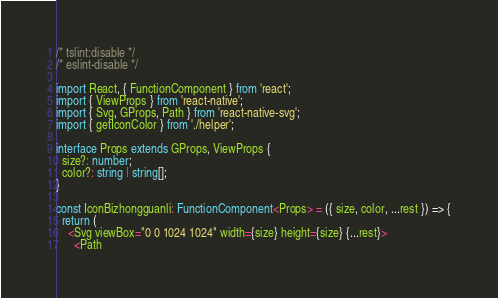<code> <loc_0><loc_0><loc_500><loc_500><_TypeScript_>/* tslint:disable */
/* eslint-disable */

import React, { FunctionComponent } from 'react';
import { ViewProps } from 'react-native';
import { Svg, GProps, Path } from 'react-native-svg';
import { getIconColor } from './helper';

interface Props extends GProps, ViewProps {
  size?: number;
  color?: string | string[];
}

const IconBizhongguanli: FunctionComponent<Props> = ({ size, color, ...rest }) => {
  return (
    <Svg viewBox="0 0 1024 1024" width={size} height={size} {...rest}>
      <Path</code> 